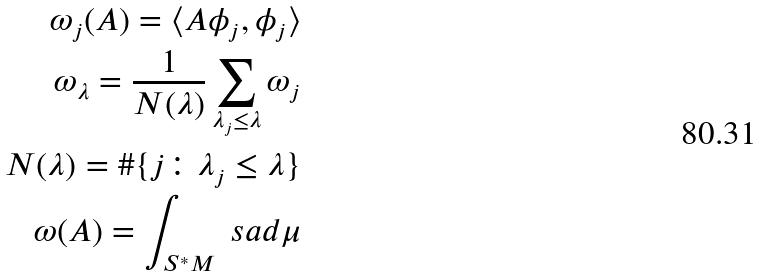<formula> <loc_0><loc_0><loc_500><loc_500>\omega _ { j } ( A ) = \langle A \phi _ { j } , \phi _ { j } \rangle \\ \omega _ { \lambda } = \frac { 1 } { N ( \lambda ) } \sum _ { \lambda _ { j } \leq \lambda } \omega _ { j } \\ N ( \lambda ) = \# \{ j \colon \lambda _ { j } \leq \lambda \} \\ \omega ( A ) = \int _ { S ^ { * } M } \ s a d \mu</formula> 